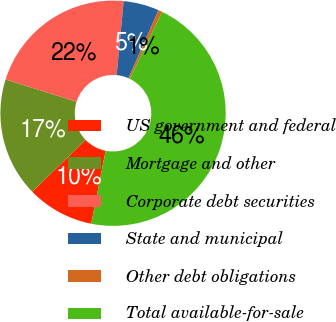Convert chart to OTSL. <chart><loc_0><loc_0><loc_500><loc_500><pie_chart><fcel>US government and federal<fcel>Mortgage and other<fcel>Corporate debt securities<fcel>State and municipal<fcel>Other debt obligations<fcel>Total available-for-sale<nl><fcel>9.64%<fcel>17.11%<fcel>21.65%<fcel>5.11%<fcel>0.57%<fcel>45.92%<nl></chart> 